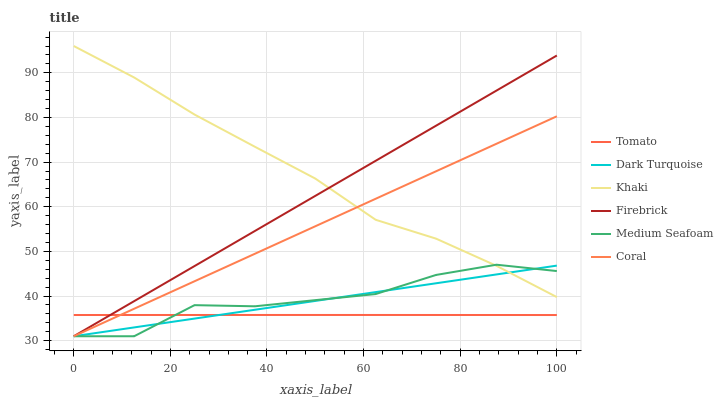Does Dark Turquoise have the minimum area under the curve?
Answer yes or no. No. Does Dark Turquoise have the maximum area under the curve?
Answer yes or no. No. Is Khaki the smoothest?
Answer yes or no. No. Is Khaki the roughest?
Answer yes or no. No. Does Khaki have the lowest value?
Answer yes or no. No. Does Dark Turquoise have the highest value?
Answer yes or no. No. Is Tomato less than Khaki?
Answer yes or no. Yes. Is Khaki greater than Tomato?
Answer yes or no. Yes. Does Tomato intersect Khaki?
Answer yes or no. No. 